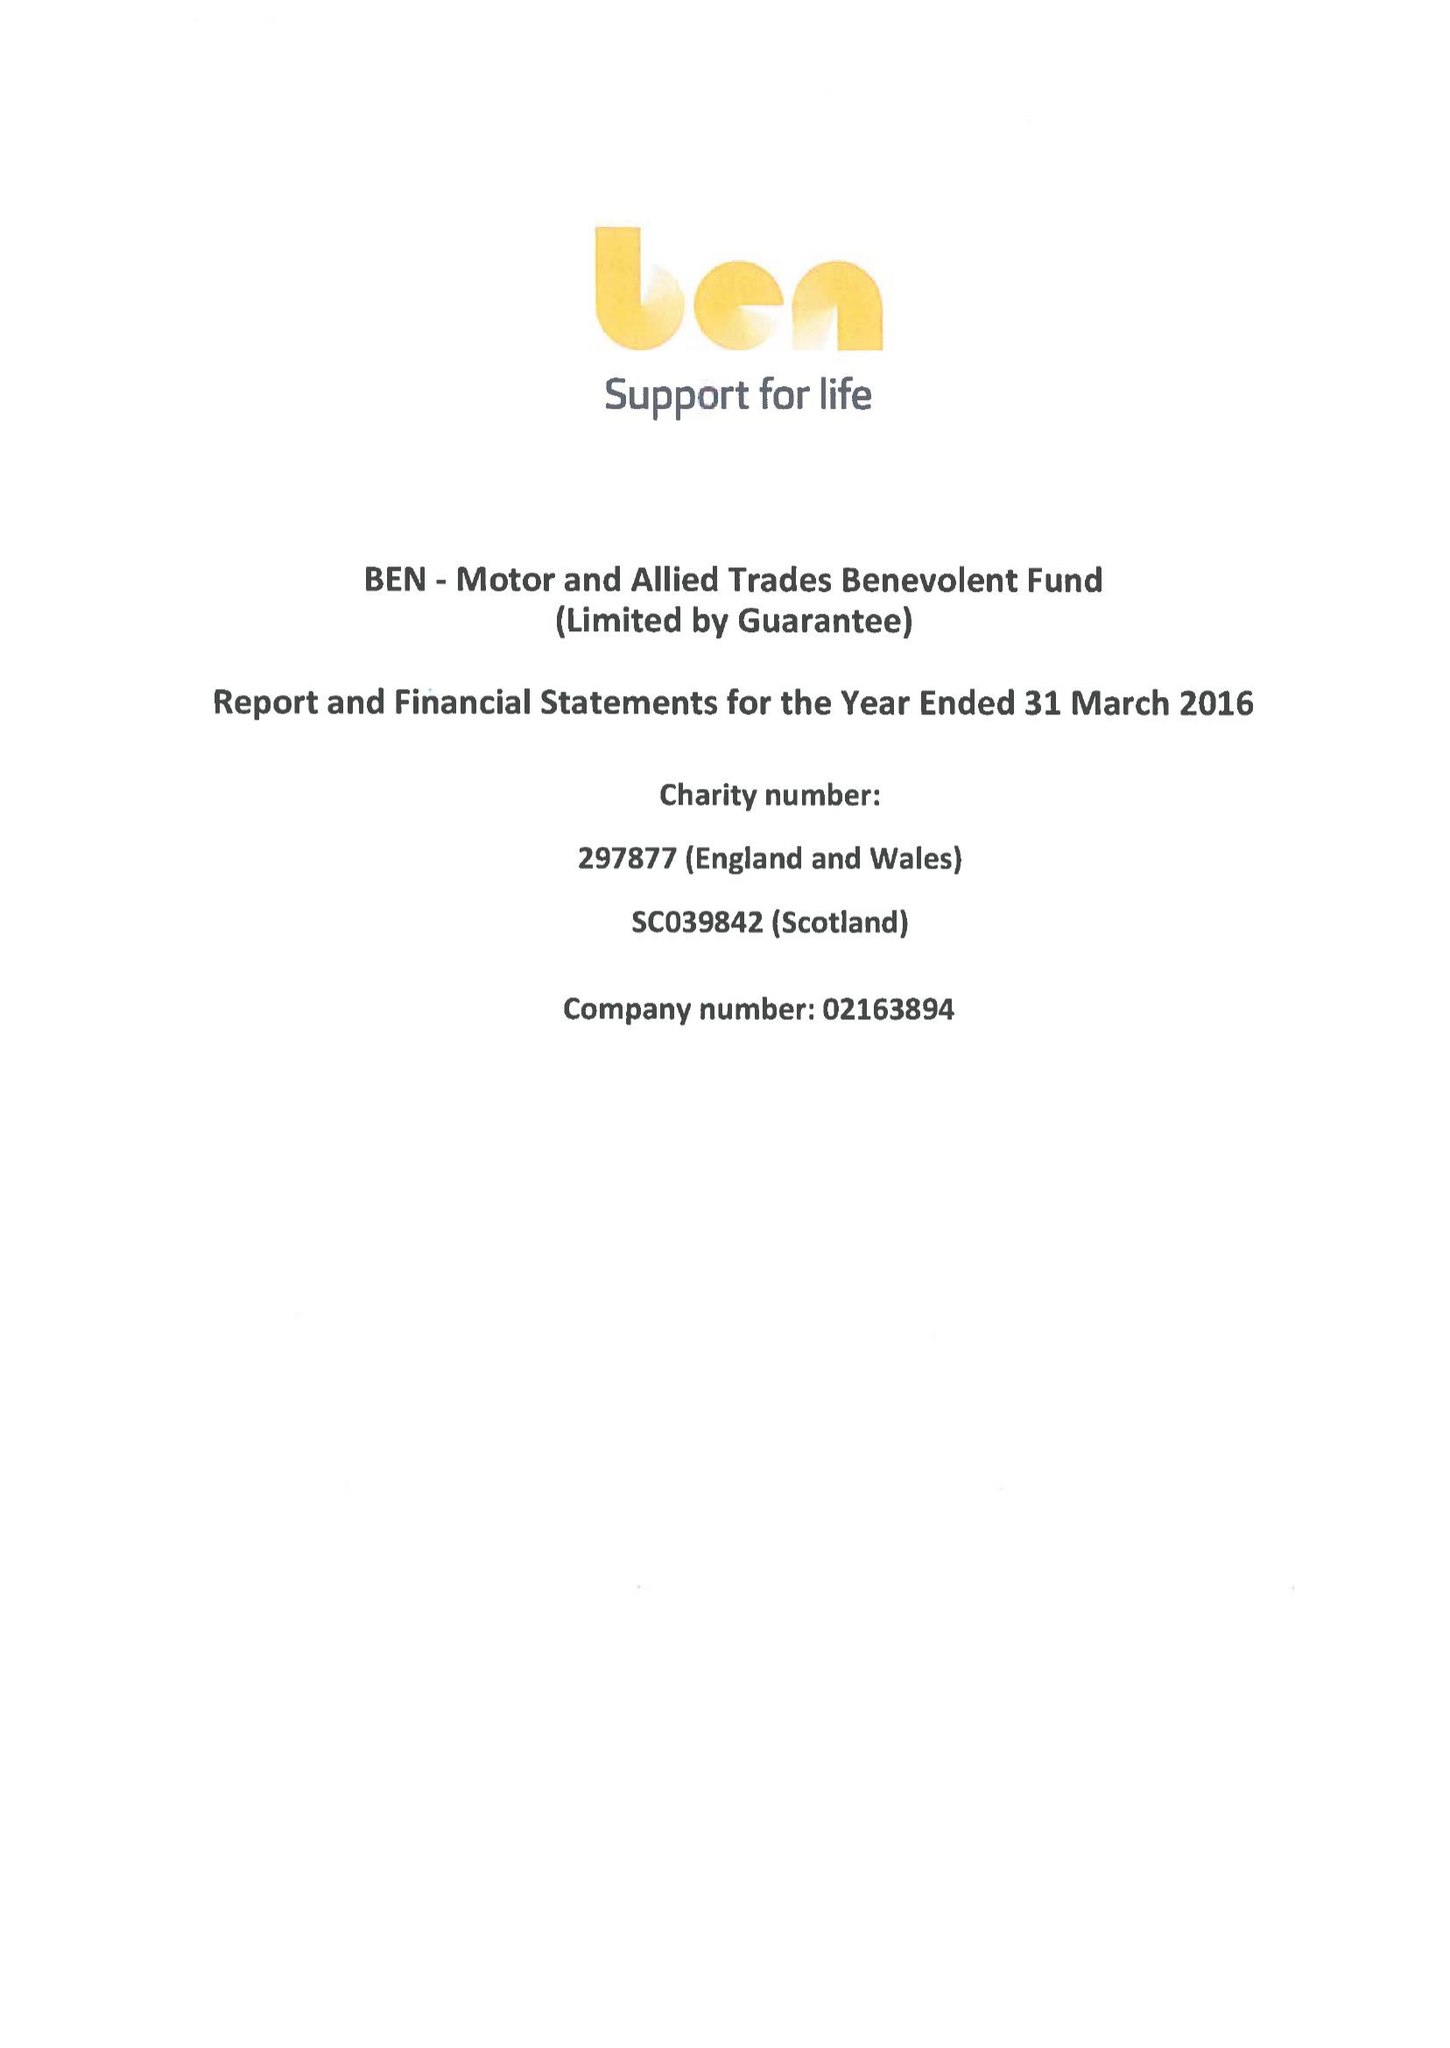What is the value for the address__post_town?
Answer the question using a single word or phrase. ASCOT 